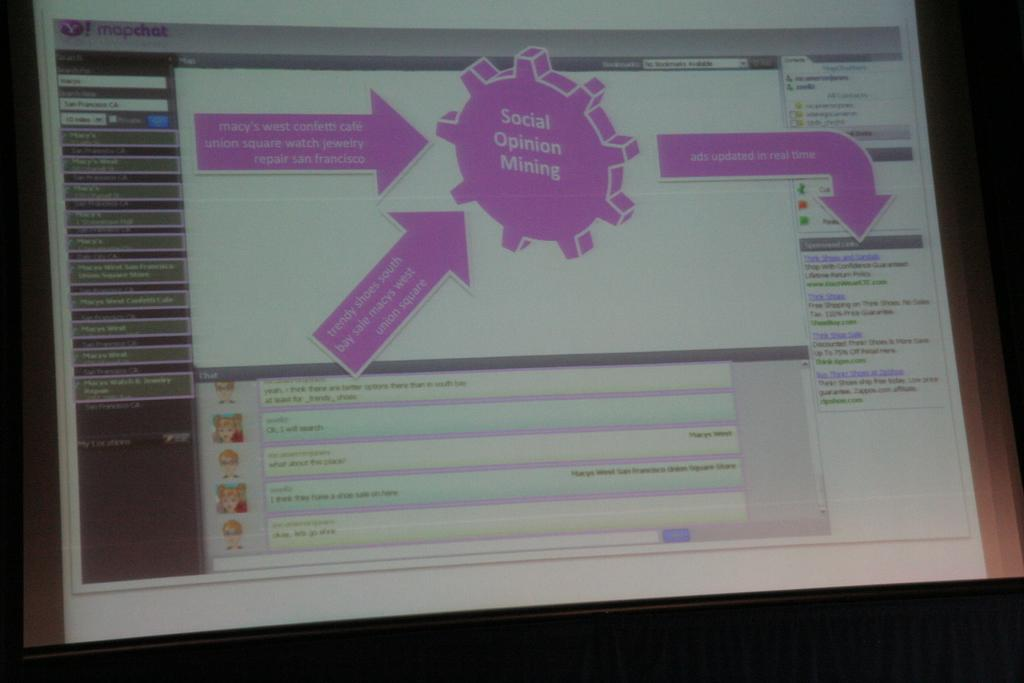<image>
Summarize the visual content of the image. Computer monitor screen with the words Social Opinion Mining on top. 